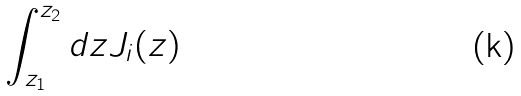<formula> <loc_0><loc_0><loc_500><loc_500>\int ^ { z _ { 2 } } _ { z _ { 1 } } d z J _ { i } ( z )</formula> 